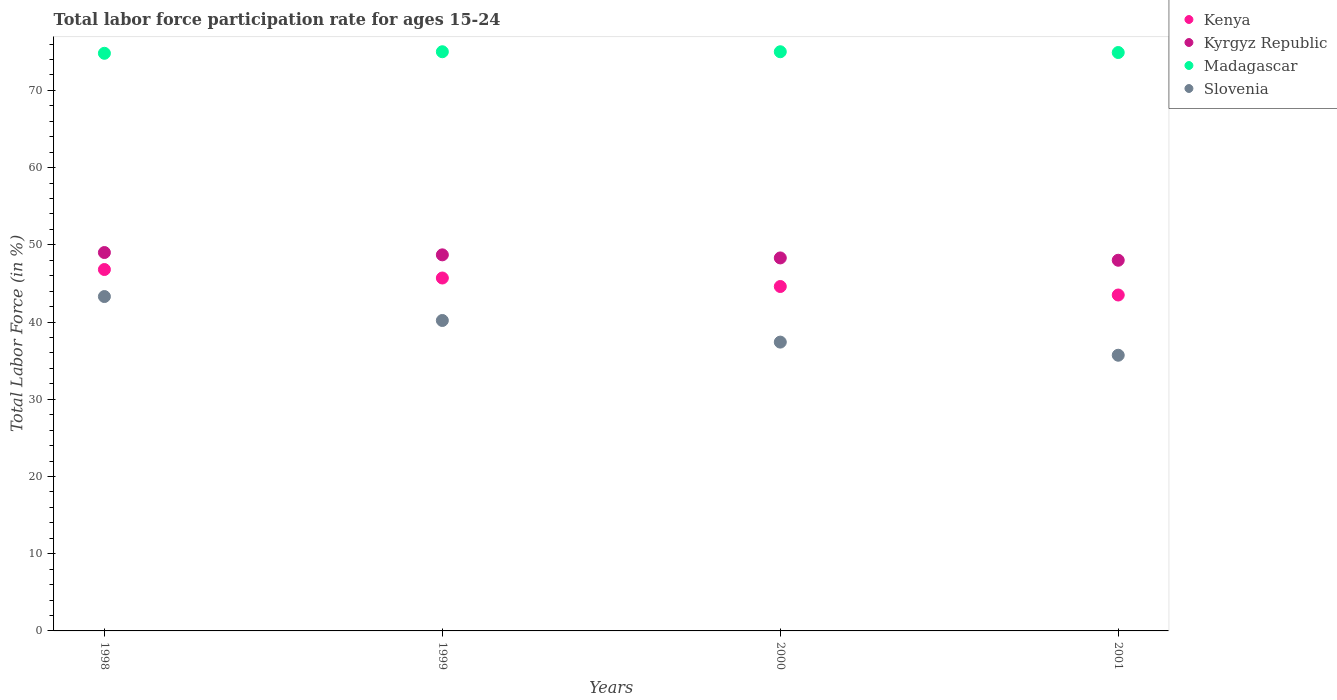How many different coloured dotlines are there?
Provide a succinct answer. 4. What is the labor force participation rate in Slovenia in 1998?
Your answer should be compact. 43.3. Across all years, what is the minimum labor force participation rate in Slovenia?
Keep it short and to the point. 35.7. In which year was the labor force participation rate in Kenya maximum?
Make the answer very short. 1998. In which year was the labor force participation rate in Madagascar minimum?
Keep it short and to the point. 1998. What is the total labor force participation rate in Madagascar in the graph?
Provide a succinct answer. 299.7. What is the difference between the labor force participation rate in Kenya in 1998 and that in 1999?
Your answer should be compact. 1.1. What is the difference between the labor force participation rate in Kyrgyz Republic in 1998 and the labor force participation rate in Kenya in 2000?
Give a very brief answer. 4.4. What is the average labor force participation rate in Kenya per year?
Offer a terse response. 45.15. In how many years, is the labor force participation rate in Kenya greater than 10 %?
Ensure brevity in your answer.  4. What is the ratio of the labor force participation rate in Madagascar in 2000 to that in 2001?
Your answer should be very brief. 1. Is the difference between the labor force participation rate in Kenya in 1998 and 2000 greater than the difference between the labor force participation rate in Kyrgyz Republic in 1998 and 2000?
Your response must be concise. Yes. What is the difference between the highest and the second highest labor force participation rate in Kenya?
Keep it short and to the point. 1.1. What is the difference between the highest and the lowest labor force participation rate in Kenya?
Offer a very short reply. 3.3. In how many years, is the labor force participation rate in Slovenia greater than the average labor force participation rate in Slovenia taken over all years?
Your response must be concise. 2. Is the sum of the labor force participation rate in Madagascar in 1998 and 2001 greater than the maximum labor force participation rate in Kenya across all years?
Ensure brevity in your answer.  Yes. Is it the case that in every year, the sum of the labor force participation rate in Madagascar and labor force participation rate in Kyrgyz Republic  is greater than the labor force participation rate in Kenya?
Provide a succinct answer. Yes. Does the labor force participation rate in Madagascar monotonically increase over the years?
Ensure brevity in your answer.  No. How many dotlines are there?
Your answer should be very brief. 4. How many years are there in the graph?
Keep it short and to the point. 4. Are the values on the major ticks of Y-axis written in scientific E-notation?
Your answer should be very brief. No. Does the graph contain any zero values?
Provide a succinct answer. No. Does the graph contain grids?
Offer a terse response. No. Where does the legend appear in the graph?
Ensure brevity in your answer.  Top right. How many legend labels are there?
Offer a terse response. 4. What is the title of the graph?
Give a very brief answer. Total labor force participation rate for ages 15-24. What is the Total Labor Force (in %) in Kenya in 1998?
Make the answer very short. 46.8. What is the Total Labor Force (in %) of Kyrgyz Republic in 1998?
Offer a terse response. 49. What is the Total Labor Force (in %) in Madagascar in 1998?
Ensure brevity in your answer.  74.8. What is the Total Labor Force (in %) in Slovenia in 1998?
Provide a short and direct response. 43.3. What is the Total Labor Force (in %) in Kenya in 1999?
Keep it short and to the point. 45.7. What is the Total Labor Force (in %) in Kyrgyz Republic in 1999?
Keep it short and to the point. 48.7. What is the Total Labor Force (in %) in Slovenia in 1999?
Your response must be concise. 40.2. What is the Total Labor Force (in %) in Kenya in 2000?
Your answer should be very brief. 44.6. What is the Total Labor Force (in %) in Kyrgyz Republic in 2000?
Provide a short and direct response. 48.3. What is the Total Labor Force (in %) of Slovenia in 2000?
Your response must be concise. 37.4. What is the Total Labor Force (in %) of Kenya in 2001?
Make the answer very short. 43.5. What is the Total Labor Force (in %) of Madagascar in 2001?
Offer a very short reply. 74.9. What is the Total Labor Force (in %) of Slovenia in 2001?
Keep it short and to the point. 35.7. Across all years, what is the maximum Total Labor Force (in %) of Kenya?
Your answer should be compact. 46.8. Across all years, what is the maximum Total Labor Force (in %) in Kyrgyz Republic?
Provide a short and direct response. 49. Across all years, what is the maximum Total Labor Force (in %) of Madagascar?
Give a very brief answer. 75. Across all years, what is the maximum Total Labor Force (in %) of Slovenia?
Your answer should be very brief. 43.3. Across all years, what is the minimum Total Labor Force (in %) in Kenya?
Keep it short and to the point. 43.5. Across all years, what is the minimum Total Labor Force (in %) in Kyrgyz Republic?
Your answer should be compact. 48. Across all years, what is the minimum Total Labor Force (in %) of Madagascar?
Your answer should be very brief. 74.8. Across all years, what is the minimum Total Labor Force (in %) in Slovenia?
Your answer should be very brief. 35.7. What is the total Total Labor Force (in %) of Kenya in the graph?
Provide a succinct answer. 180.6. What is the total Total Labor Force (in %) in Kyrgyz Republic in the graph?
Provide a succinct answer. 194. What is the total Total Labor Force (in %) in Madagascar in the graph?
Make the answer very short. 299.7. What is the total Total Labor Force (in %) in Slovenia in the graph?
Ensure brevity in your answer.  156.6. What is the difference between the Total Labor Force (in %) of Kyrgyz Republic in 1998 and that in 1999?
Give a very brief answer. 0.3. What is the difference between the Total Labor Force (in %) of Madagascar in 1998 and that in 1999?
Make the answer very short. -0.2. What is the difference between the Total Labor Force (in %) of Kenya in 1998 and that in 2000?
Your answer should be very brief. 2.2. What is the difference between the Total Labor Force (in %) in Madagascar in 1998 and that in 2000?
Offer a very short reply. -0.2. What is the difference between the Total Labor Force (in %) in Slovenia in 1998 and that in 2000?
Provide a short and direct response. 5.9. What is the difference between the Total Labor Force (in %) in Kenya in 1998 and that in 2001?
Provide a short and direct response. 3.3. What is the difference between the Total Labor Force (in %) in Kyrgyz Republic in 1998 and that in 2001?
Provide a succinct answer. 1. What is the difference between the Total Labor Force (in %) in Kenya in 1999 and that in 2000?
Keep it short and to the point. 1.1. What is the difference between the Total Labor Force (in %) of Kyrgyz Republic in 1999 and that in 2000?
Make the answer very short. 0.4. What is the difference between the Total Labor Force (in %) in Kenya in 1999 and that in 2001?
Your answer should be compact. 2.2. What is the difference between the Total Labor Force (in %) in Kyrgyz Republic in 2000 and that in 2001?
Provide a short and direct response. 0.3. What is the difference between the Total Labor Force (in %) in Madagascar in 2000 and that in 2001?
Provide a succinct answer. 0.1. What is the difference between the Total Labor Force (in %) of Kenya in 1998 and the Total Labor Force (in %) of Kyrgyz Republic in 1999?
Your response must be concise. -1.9. What is the difference between the Total Labor Force (in %) in Kenya in 1998 and the Total Labor Force (in %) in Madagascar in 1999?
Your answer should be compact. -28.2. What is the difference between the Total Labor Force (in %) of Kyrgyz Republic in 1998 and the Total Labor Force (in %) of Madagascar in 1999?
Your answer should be compact. -26. What is the difference between the Total Labor Force (in %) in Madagascar in 1998 and the Total Labor Force (in %) in Slovenia in 1999?
Provide a short and direct response. 34.6. What is the difference between the Total Labor Force (in %) of Kenya in 1998 and the Total Labor Force (in %) of Kyrgyz Republic in 2000?
Give a very brief answer. -1.5. What is the difference between the Total Labor Force (in %) in Kenya in 1998 and the Total Labor Force (in %) in Madagascar in 2000?
Offer a very short reply. -28.2. What is the difference between the Total Labor Force (in %) in Kyrgyz Republic in 1998 and the Total Labor Force (in %) in Madagascar in 2000?
Provide a short and direct response. -26. What is the difference between the Total Labor Force (in %) in Kyrgyz Republic in 1998 and the Total Labor Force (in %) in Slovenia in 2000?
Your answer should be very brief. 11.6. What is the difference between the Total Labor Force (in %) of Madagascar in 1998 and the Total Labor Force (in %) of Slovenia in 2000?
Keep it short and to the point. 37.4. What is the difference between the Total Labor Force (in %) in Kenya in 1998 and the Total Labor Force (in %) in Kyrgyz Republic in 2001?
Your response must be concise. -1.2. What is the difference between the Total Labor Force (in %) in Kenya in 1998 and the Total Labor Force (in %) in Madagascar in 2001?
Offer a very short reply. -28.1. What is the difference between the Total Labor Force (in %) in Kenya in 1998 and the Total Labor Force (in %) in Slovenia in 2001?
Keep it short and to the point. 11.1. What is the difference between the Total Labor Force (in %) of Kyrgyz Republic in 1998 and the Total Labor Force (in %) of Madagascar in 2001?
Provide a short and direct response. -25.9. What is the difference between the Total Labor Force (in %) of Kyrgyz Republic in 1998 and the Total Labor Force (in %) of Slovenia in 2001?
Make the answer very short. 13.3. What is the difference between the Total Labor Force (in %) of Madagascar in 1998 and the Total Labor Force (in %) of Slovenia in 2001?
Ensure brevity in your answer.  39.1. What is the difference between the Total Labor Force (in %) in Kenya in 1999 and the Total Labor Force (in %) in Madagascar in 2000?
Give a very brief answer. -29.3. What is the difference between the Total Labor Force (in %) of Kenya in 1999 and the Total Labor Force (in %) of Slovenia in 2000?
Your response must be concise. 8.3. What is the difference between the Total Labor Force (in %) of Kyrgyz Republic in 1999 and the Total Labor Force (in %) of Madagascar in 2000?
Your response must be concise. -26.3. What is the difference between the Total Labor Force (in %) of Kyrgyz Republic in 1999 and the Total Labor Force (in %) of Slovenia in 2000?
Provide a short and direct response. 11.3. What is the difference between the Total Labor Force (in %) in Madagascar in 1999 and the Total Labor Force (in %) in Slovenia in 2000?
Your answer should be very brief. 37.6. What is the difference between the Total Labor Force (in %) in Kenya in 1999 and the Total Labor Force (in %) in Madagascar in 2001?
Your answer should be compact. -29.2. What is the difference between the Total Labor Force (in %) of Kenya in 1999 and the Total Labor Force (in %) of Slovenia in 2001?
Give a very brief answer. 10. What is the difference between the Total Labor Force (in %) of Kyrgyz Republic in 1999 and the Total Labor Force (in %) of Madagascar in 2001?
Provide a succinct answer. -26.2. What is the difference between the Total Labor Force (in %) of Madagascar in 1999 and the Total Labor Force (in %) of Slovenia in 2001?
Provide a short and direct response. 39.3. What is the difference between the Total Labor Force (in %) of Kenya in 2000 and the Total Labor Force (in %) of Madagascar in 2001?
Provide a succinct answer. -30.3. What is the difference between the Total Labor Force (in %) of Kenya in 2000 and the Total Labor Force (in %) of Slovenia in 2001?
Your answer should be very brief. 8.9. What is the difference between the Total Labor Force (in %) in Kyrgyz Republic in 2000 and the Total Labor Force (in %) in Madagascar in 2001?
Ensure brevity in your answer.  -26.6. What is the difference between the Total Labor Force (in %) of Kyrgyz Republic in 2000 and the Total Labor Force (in %) of Slovenia in 2001?
Give a very brief answer. 12.6. What is the difference between the Total Labor Force (in %) in Madagascar in 2000 and the Total Labor Force (in %) in Slovenia in 2001?
Offer a very short reply. 39.3. What is the average Total Labor Force (in %) of Kenya per year?
Your answer should be compact. 45.15. What is the average Total Labor Force (in %) in Kyrgyz Republic per year?
Make the answer very short. 48.5. What is the average Total Labor Force (in %) in Madagascar per year?
Provide a short and direct response. 74.92. What is the average Total Labor Force (in %) in Slovenia per year?
Provide a short and direct response. 39.15. In the year 1998, what is the difference between the Total Labor Force (in %) of Kenya and Total Labor Force (in %) of Kyrgyz Republic?
Provide a short and direct response. -2.2. In the year 1998, what is the difference between the Total Labor Force (in %) in Kyrgyz Republic and Total Labor Force (in %) in Madagascar?
Offer a very short reply. -25.8. In the year 1998, what is the difference between the Total Labor Force (in %) in Madagascar and Total Labor Force (in %) in Slovenia?
Your answer should be compact. 31.5. In the year 1999, what is the difference between the Total Labor Force (in %) of Kenya and Total Labor Force (in %) of Kyrgyz Republic?
Offer a very short reply. -3. In the year 1999, what is the difference between the Total Labor Force (in %) in Kenya and Total Labor Force (in %) in Madagascar?
Provide a succinct answer. -29.3. In the year 1999, what is the difference between the Total Labor Force (in %) of Kyrgyz Republic and Total Labor Force (in %) of Madagascar?
Keep it short and to the point. -26.3. In the year 1999, what is the difference between the Total Labor Force (in %) in Kyrgyz Republic and Total Labor Force (in %) in Slovenia?
Offer a very short reply. 8.5. In the year 1999, what is the difference between the Total Labor Force (in %) of Madagascar and Total Labor Force (in %) of Slovenia?
Give a very brief answer. 34.8. In the year 2000, what is the difference between the Total Labor Force (in %) of Kenya and Total Labor Force (in %) of Kyrgyz Republic?
Your answer should be compact. -3.7. In the year 2000, what is the difference between the Total Labor Force (in %) in Kenya and Total Labor Force (in %) in Madagascar?
Provide a short and direct response. -30.4. In the year 2000, what is the difference between the Total Labor Force (in %) in Kyrgyz Republic and Total Labor Force (in %) in Madagascar?
Keep it short and to the point. -26.7. In the year 2000, what is the difference between the Total Labor Force (in %) in Kyrgyz Republic and Total Labor Force (in %) in Slovenia?
Offer a terse response. 10.9. In the year 2000, what is the difference between the Total Labor Force (in %) of Madagascar and Total Labor Force (in %) of Slovenia?
Offer a terse response. 37.6. In the year 2001, what is the difference between the Total Labor Force (in %) of Kenya and Total Labor Force (in %) of Kyrgyz Republic?
Your answer should be very brief. -4.5. In the year 2001, what is the difference between the Total Labor Force (in %) in Kenya and Total Labor Force (in %) in Madagascar?
Make the answer very short. -31.4. In the year 2001, what is the difference between the Total Labor Force (in %) of Kyrgyz Republic and Total Labor Force (in %) of Madagascar?
Give a very brief answer. -26.9. In the year 2001, what is the difference between the Total Labor Force (in %) of Kyrgyz Republic and Total Labor Force (in %) of Slovenia?
Ensure brevity in your answer.  12.3. In the year 2001, what is the difference between the Total Labor Force (in %) in Madagascar and Total Labor Force (in %) in Slovenia?
Your answer should be compact. 39.2. What is the ratio of the Total Labor Force (in %) in Kenya in 1998 to that in 1999?
Provide a short and direct response. 1.02. What is the ratio of the Total Labor Force (in %) of Kyrgyz Republic in 1998 to that in 1999?
Provide a short and direct response. 1.01. What is the ratio of the Total Labor Force (in %) of Slovenia in 1998 to that in 1999?
Make the answer very short. 1.08. What is the ratio of the Total Labor Force (in %) of Kenya in 1998 to that in 2000?
Give a very brief answer. 1.05. What is the ratio of the Total Labor Force (in %) in Kyrgyz Republic in 1998 to that in 2000?
Offer a terse response. 1.01. What is the ratio of the Total Labor Force (in %) of Slovenia in 1998 to that in 2000?
Give a very brief answer. 1.16. What is the ratio of the Total Labor Force (in %) of Kenya in 1998 to that in 2001?
Ensure brevity in your answer.  1.08. What is the ratio of the Total Labor Force (in %) in Kyrgyz Republic in 1998 to that in 2001?
Provide a short and direct response. 1.02. What is the ratio of the Total Labor Force (in %) of Slovenia in 1998 to that in 2001?
Make the answer very short. 1.21. What is the ratio of the Total Labor Force (in %) of Kenya in 1999 to that in 2000?
Give a very brief answer. 1.02. What is the ratio of the Total Labor Force (in %) of Kyrgyz Republic in 1999 to that in 2000?
Keep it short and to the point. 1.01. What is the ratio of the Total Labor Force (in %) in Slovenia in 1999 to that in 2000?
Give a very brief answer. 1.07. What is the ratio of the Total Labor Force (in %) of Kenya in 1999 to that in 2001?
Provide a succinct answer. 1.05. What is the ratio of the Total Labor Force (in %) of Kyrgyz Republic in 1999 to that in 2001?
Give a very brief answer. 1.01. What is the ratio of the Total Labor Force (in %) in Slovenia in 1999 to that in 2001?
Your response must be concise. 1.13. What is the ratio of the Total Labor Force (in %) in Kenya in 2000 to that in 2001?
Offer a very short reply. 1.03. What is the ratio of the Total Labor Force (in %) of Kyrgyz Republic in 2000 to that in 2001?
Keep it short and to the point. 1.01. What is the ratio of the Total Labor Force (in %) in Slovenia in 2000 to that in 2001?
Keep it short and to the point. 1.05. What is the difference between the highest and the second highest Total Labor Force (in %) of Madagascar?
Offer a terse response. 0. What is the difference between the highest and the lowest Total Labor Force (in %) in Slovenia?
Make the answer very short. 7.6. 